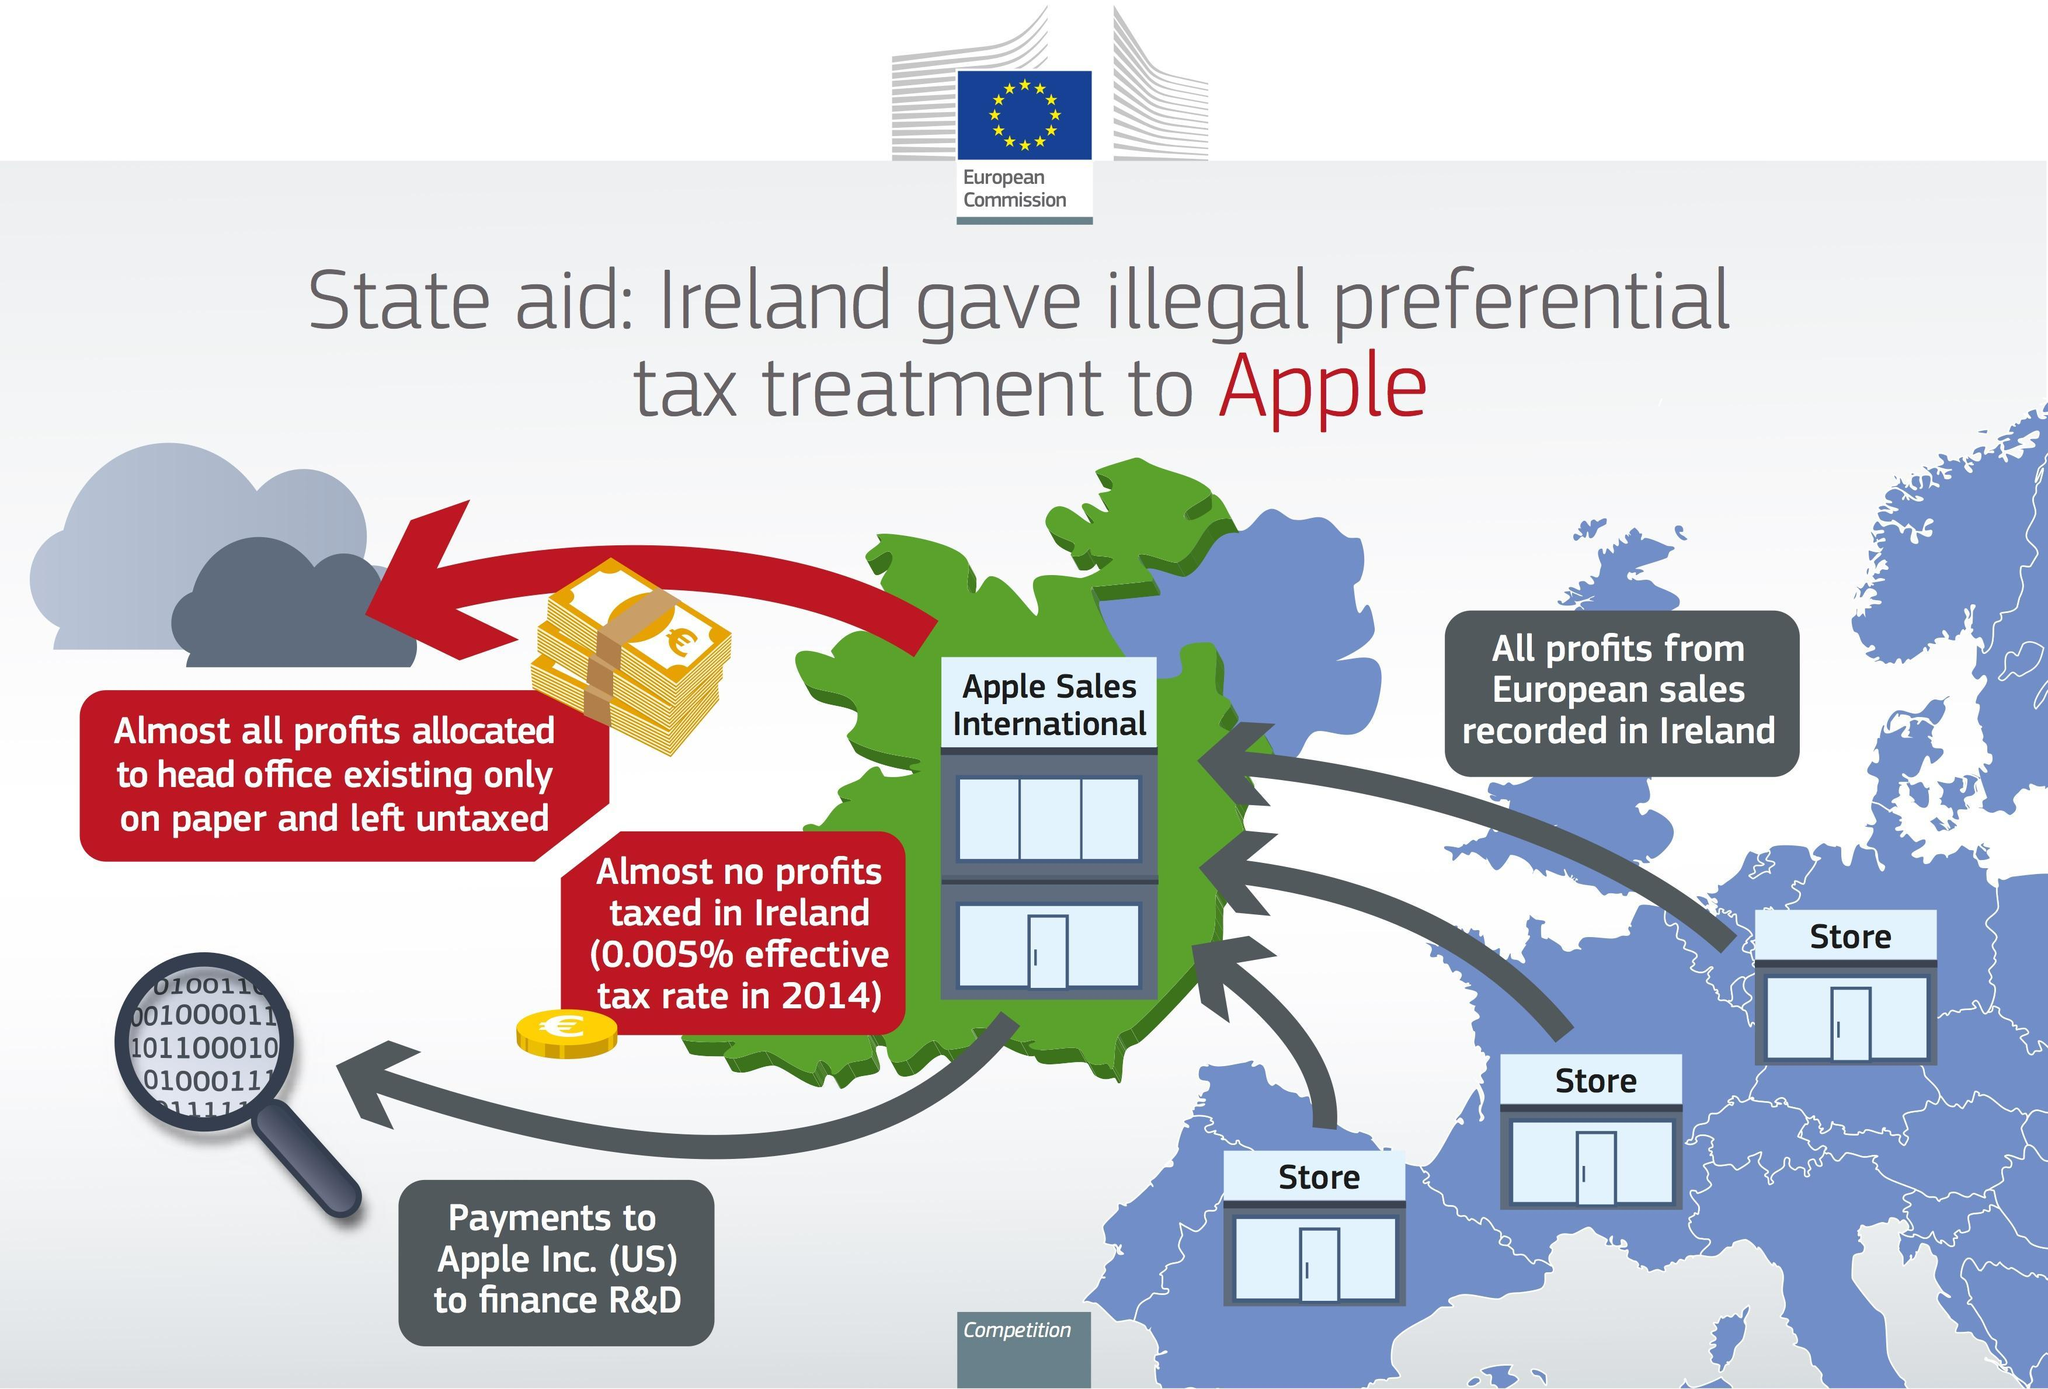In which countries does Apple have its offices and stores?
Answer the question with a short phrase. US, Ireland 